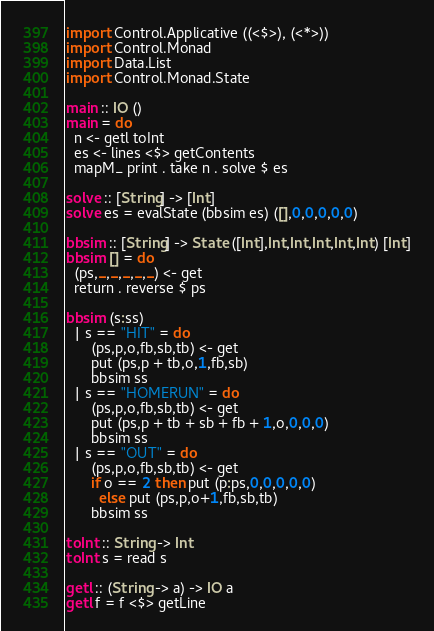Convert code to text. <code><loc_0><loc_0><loc_500><loc_500><_Haskell_>import Control.Applicative ((<$>), (<*>))
import Control.Monad
import Data.List
import Control.Monad.State

main :: IO ()
main = do
  n <- getl toInt
  es <- lines <$> getContents
  mapM_ print . take n . solve $ es

solve :: [String] -> [Int]
solve es = evalState (bbsim es) ([],0,0,0,0,0)

bbsim :: [String] -> State ([Int],Int,Int,Int,Int,Int) [Int]
bbsim [] = do
  (ps,_,_,_,_,_) <- get
  return . reverse $ ps

bbsim (s:ss)
  | s == "HIT" = do
      (ps,p,o,fb,sb,tb) <- get
      put (ps,p + tb,o,1,fb,sb)
      bbsim ss
  | s == "HOMERUN" = do
      (ps,p,o,fb,sb,tb) <- get
      put (ps,p + tb + sb + fb + 1,o,0,0,0)
      bbsim ss
  | s == "OUT" = do
      (ps,p,o,fb,sb,tb) <- get
      if o == 2 then put (p:ps,0,0,0,0,0)
        else put (ps,p,o+1,fb,sb,tb)
      bbsim ss

toInt :: String -> Int
toInt s = read s

getl :: (String -> a) -> IO a
getl f = f <$> getLine</code> 